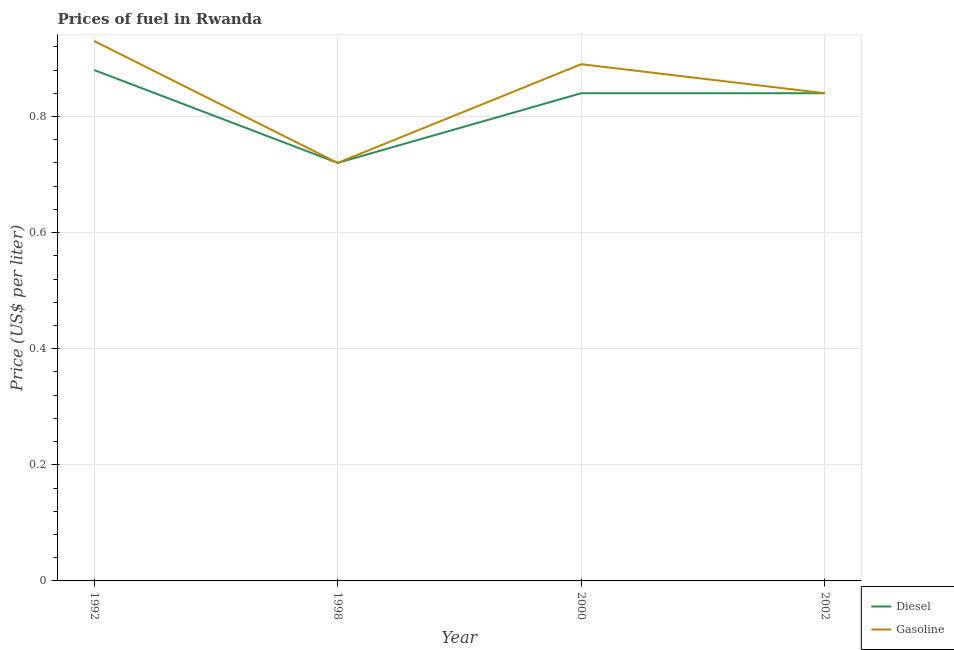How many different coloured lines are there?
Give a very brief answer. 2. Is the number of lines equal to the number of legend labels?
Give a very brief answer. Yes. What is the diesel price in 2002?
Provide a short and direct response. 0.84. Across all years, what is the maximum diesel price?
Offer a terse response. 0.88. Across all years, what is the minimum gasoline price?
Offer a terse response. 0.72. In which year was the gasoline price maximum?
Your response must be concise. 1992. What is the total diesel price in the graph?
Your answer should be very brief. 3.28. What is the difference between the diesel price in 1998 and that in 2000?
Your answer should be compact. -0.12. What is the difference between the diesel price in 2002 and the gasoline price in 1992?
Make the answer very short. -0.09. What is the average gasoline price per year?
Make the answer very short. 0.84. In the year 2000, what is the difference between the gasoline price and diesel price?
Offer a terse response. 0.05. What is the ratio of the gasoline price in 1992 to that in 2000?
Give a very brief answer. 1.04. Is the diesel price in 1992 less than that in 1998?
Offer a terse response. No. Is the difference between the gasoline price in 1992 and 1998 greater than the difference between the diesel price in 1992 and 1998?
Offer a very short reply. Yes. What is the difference between the highest and the second highest diesel price?
Your answer should be compact. 0.04. What is the difference between the highest and the lowest diesel price?
Offer a terse response. 0.16. Is the sum of the gasoline price in 1992 and 2000 greater than the maximum diesel price across all years?
Make the answer very short. Yes. Does the gasoline price monotonically increase over the years?
Keep it short and to the point. No. Is the gasoline price strictly greater than the diesel price over the years?
Your answer should be compact. No. Is the gasoline price strictly less than the diesel price over the years?
Keep it short and to the point. No. How many lines are there?
Keep it short and to the point. 2. What is the difference between two consecutive major ticks on the Y-axis?
Provide a short and direct response. 0.2. Does the graph contain grids?
Ensure brevity in your answer.  Yes. How many legend labels are there?
Keep it short and to the point. 2. What is the title of the graph?
Ensure brevity in your answer.  Prices of fuel in Rwanda. What is the label or title of the X-axis?
Provide a succinct answer. Year. What is the label or title of the Y-axis?
Make the answer very short. Price (US$ per liter). What is the Price (US$ per liter) of Diesel in 1998?
Make the answer very short. 0.72. What is the Price (US$ per liter) in Gasoline in 1998?
Provide a succinct answer. 0.72. What is the Price (US$ per liter) of Diesel in 2000?
Offer a very short reply. 0.84. What is the Price (US$ per liter) in Gasoline in 2000?
Your answer should be compact. 0.89. What is the Price (US$ per liter) in Diesel in 2002?
Make the answer very short. 0.84. What is the Price (US$ per liter) of Gasoline in 2002?
Make the answer very short. 0.84. Across all years, what is the minimum Price (US$ per liter) of Diesel?
Your response must be concise. 0.72. Across all years, what is the minimum Price (US$ per liter) of Gasoline?
Offer a terse response. 0.72. What is the total Price (US$ per liter) in Diesel in the graph?
Your answer should be compact. 3.28. What is the total Price (US$ per liter) of Gasoline in the graph?
Offer a very short reply. 3.38. What is the difference between the Price (US$ per liter) of Diesel in 1992 and that in 1998?
Provide a short and direct response. 0.16. What is the difference between the Price (US$ per liter) in Gasoline in 1992 and that in 1998?
Offer a very short reply. 0.21. What is the difference between the Price (US$ per liter) in Gasoline in 1992 and that in 2000?
Your response must be concise. 0.04. What is the difference between the Price (US$ per liter) of Gasoline in 1992 and that in 2002?
Ensure brevity in your answer.  0.09. What is the difference between the Price (US$ per liter) of Diesel in 1998 and that in 2000?
Keep it short and to the point. -0.12. What is the difference between the Price (US$ per liter) in Gasoline in 1998 and that in 2000?
Make the answer very short. -0.17. What is the difference between the Price (US$ per liter) in Diesel in 1998 and that in 2002?
Offer a very short reply. -0.12. What is the difference between the Price (US$ per liter) of Gasoline in 1998 and that in 2002?
Ensure brevity in your answer.  -0.12. What is the difference between the Price (US$ per liter) of Gasoline in 2000 and that in 2002?
Keep it short and to the point. 0.05. What is the difference between the Price (US$ per liter) of Diesel in 1992 and the Price (US$ per liter) of Gasoline in 1998?
Ensure brevity in your answer.  0.16. What is the difference between the Price (US$ per liter) in Diesel in 1992 and the Price (US$ per liter) in Gasoline in 2000?
Your answer should be compact. -0.01. What is the difference between the Price (US$ per liter) of Diesel in 1992 and the Price (US$ per liter) of Gasoline in 2002?
Give a very brief answer. 0.04. What is the difference between the Price (US$ per liter) of Diesel in 1998 and the Price (US$ per liter) of Gasoline in 2000?
Offer a terse response. -0.17. What is the difference between the Price (US$ per liter) of Diesel in 1998 and the Price (US$ per liter) of Gasoline in 2002?
Keep it short and to the point. -0.12. What is the difference between the Price (US$ per liter) of Diesel in 2000 and the Price (US$ per liter) of Gasoline in 2002?
Ensure brevity in your answer.  0. What is the average Price (US$ per liter) of Diesel per year?
Keep it short and to the point. 0.82. What is the average Price (US$ per liter) of Gasoline per year?
Offer a terse response. 0.84. In the year 1992, what is the difference between the Price (US$ per liter) in Diesel and Price (US$ per liter) in Gasoline?
Your answer should be very brief. -0.05. In the year 1998, what is the difference between the Price (US$ per liter) of Diesel and Price (US$ per liter) of Gasoline?
Offer a very short reply. 0. In the year 2002, what is the difference between the Price (US$ per liter) of Diesel and Price (US$ per liter) of Gasoline?
Provide a succinct answer. 0. What is the ratio of the Price (US$ per liter) of Diesel in 1992 to that in 1998?
Ensure brevity in your answer.  1.22. What is the ratio of the Price (US$ per liter) in Gasoline in 1992 to that in 1998?
Your response must be concise. 1.29. What is the ratio of the Price (US$ per liter) of Diesel in 1992 to that in 2000?
Provide a short and direct response. 1.05. What is the ratio of the Price (US$ per liter) of Gasoline in 1992 to that in 2000?
Make the answer very short. 1.04. What is the ratio of the Price (US$ per liter) in Diesel in 1992 to that in 2002?
Give a very brief answer. 1.05. What is the ratio of the Price (US$ per liter) in Gasoline in 1992 to that in 2002?
Your answer should be compact. 1.11. What is the ratio of the Price (US$ per liter) in Gasoline in 1998 to that in 2000?
Your answer should be very brief. 0.81. What is the ratio of the Price (US$ per liter) in Diesel in 1998 to that in 2002?
Offer a very short reply. 0.86. What is the ratio of the Price (US$ per liter) in Gasoline in 2000 to that in 2002?
Ensure brevity in your answer.  1.06. What is the difference between the highest and the second highest Price (US$ per liter) of Diesel?
Ensure brevity in your answer.  0.04. What is the difference between the highest and the lowest Price (US$ per liter) of Diesel?
Provide a succinct answer. 0.16. What is the difference between the highest and the lowest Price (US$ per liter) in Gasoline?
Ensure brevity in your answer.  0.21. 